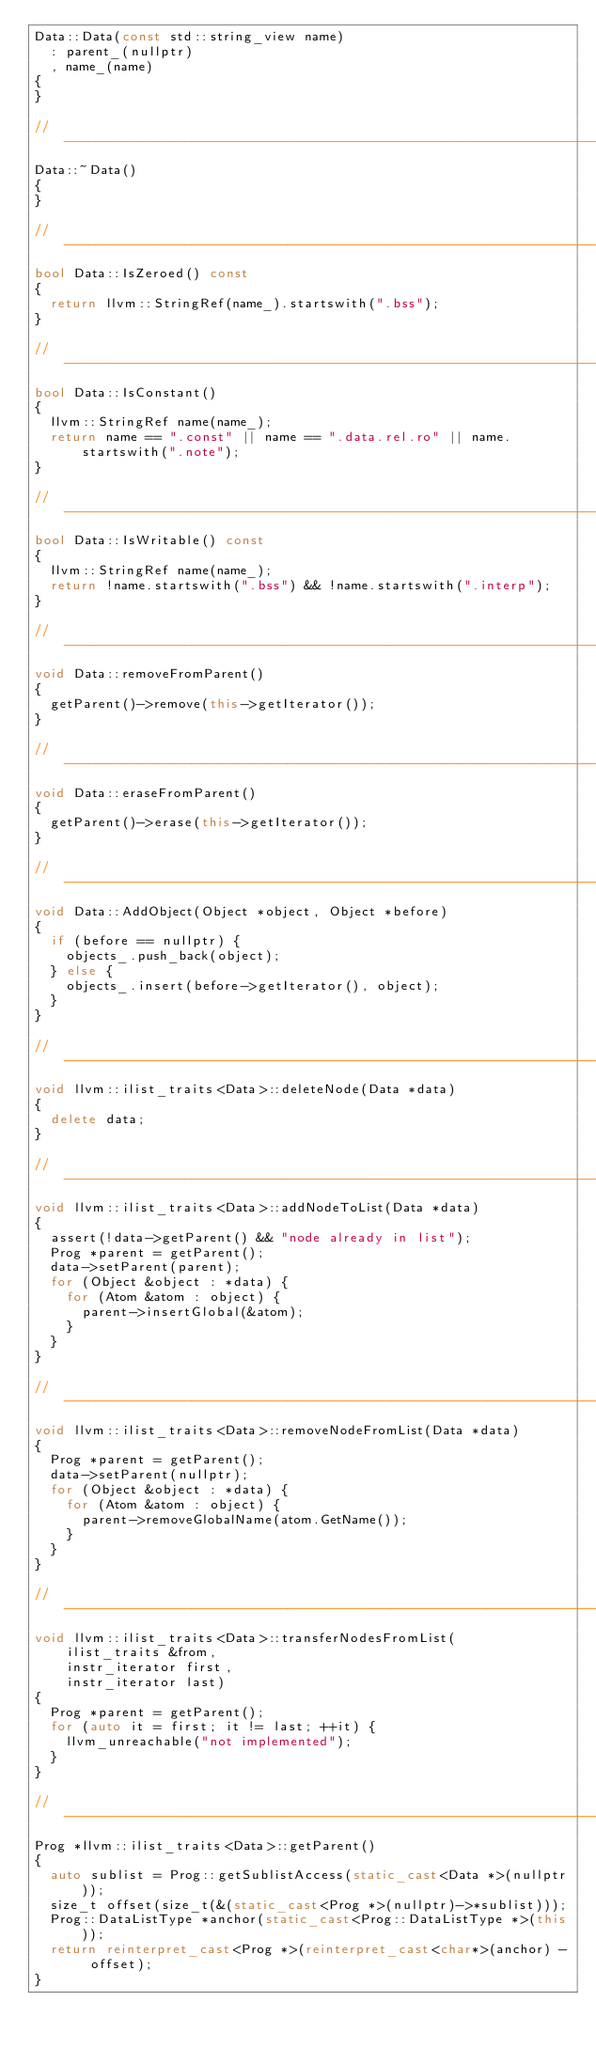Convert code to text. <code><loc_0><loc_0><loc_500><loc_500><_C++_>Data::Data(const std::string_view name)
  : parent_(nullptr)
  , name_(name)
{
}

// -----------------------------------------------------------------------------
Data::~Data()
{
}

// -----------------------------------------------------------------------------
bool Data::IsZeroed() const
{
  return llvm::StringRef(name_).startswith(".bss");
}

// -----------------------------------------------------------------------------
bool Data::IsConstant()
{
  llvm::StringRef name(name_);
  return name == ".const" || name == ".data.rel.ro" || name.startswith(".note");
}

// -----------------------------------------------------------------------------
bool Data::IsWritable() const
{
  llvm::StringRef name(name_);
  return !name.startswith(".bss") && !name.startswith(".interp");
}

// -----------------------------------------------------------------------------
void Data::removeFromParent()
{
  getParent()->remove(this->getIterator());
}

// -----------------------------------------------------------------------------
void Data::eraseFromParent()
{
  getParent()->erase(this->getIterator());
}

// -----------------------------------------------------------------------------
void Data::AddObject(Object *object, Object *before)
{
  if (before == nullptr) {
    objects_.push_back(object);
  } else {
    objects_.insert(before->getIterator(), object);
  }
}

// -----------------------------------------------------------------------------
void llvm::ilist_traits<Data>::deleteNode(Data *data)
{
  delete data;
}

// -----------------------------------------------------------------------------
void llvm::ilist_traits<Data>::addNodeToList(Data *data)
{
  assert(!data->getParent() && "node already in list");
  Prog *parent = getParent();
  data->setParent(parent);
  for (Object &object : *data) {
    for (Atom &atom : object) {
      parent->insertGlobal(&atom);
    }
  }
}

// -----------------------------------------------------------------------------
void llvm::ilist_traits<Data>::removeNodeFromList(Data *data)
{
  Prog *parent = getParent();
  data->setParent(nullptr);
  for (Object &object : *data) {
    for (Atom &atom : object) {
      parent->removeGlobalName(atom.GetName());
    }
  }
}

// -----------------------------------------------------------------------------
void llvm::ilist_traits<Data>::transferNodesFromList(
    ilist_traits &from,
    instr_iterator first,
    instr_iterator last)
{
  Prog *parent = getParent();
  for (auto it = first; it != last; ++it) {
    llvm_unreachable("not implemented");
  }
}

// -----------------------------------------------------------------------------
Prog *llvm::ilist_traits<Data>::getParent()
{
  auto sublist = Prog::getSublistAccess(static_cast<Data *>(nullptr));
  size_t offset(size_t(&(static_cast<Prog *>(nullptr)->*sublist)));
  Prog::DataListType *anchor(static_cast<Prog::DataListType *>(this));
  return reinterpret_cast<Prog *>(reinterpret_cast<char*>(anchor) - offset);
}
</code> 